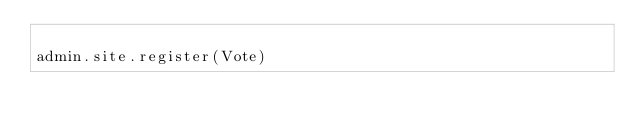<code> <loc_0><loc_0><loc_500><loc_500><_Python_>
admin.site.register(Vote)</code> 